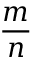Convert formula to latex. <formula><loc_0><loc_0><loc_500><loc_500>\frac { m } { n }</formula> 